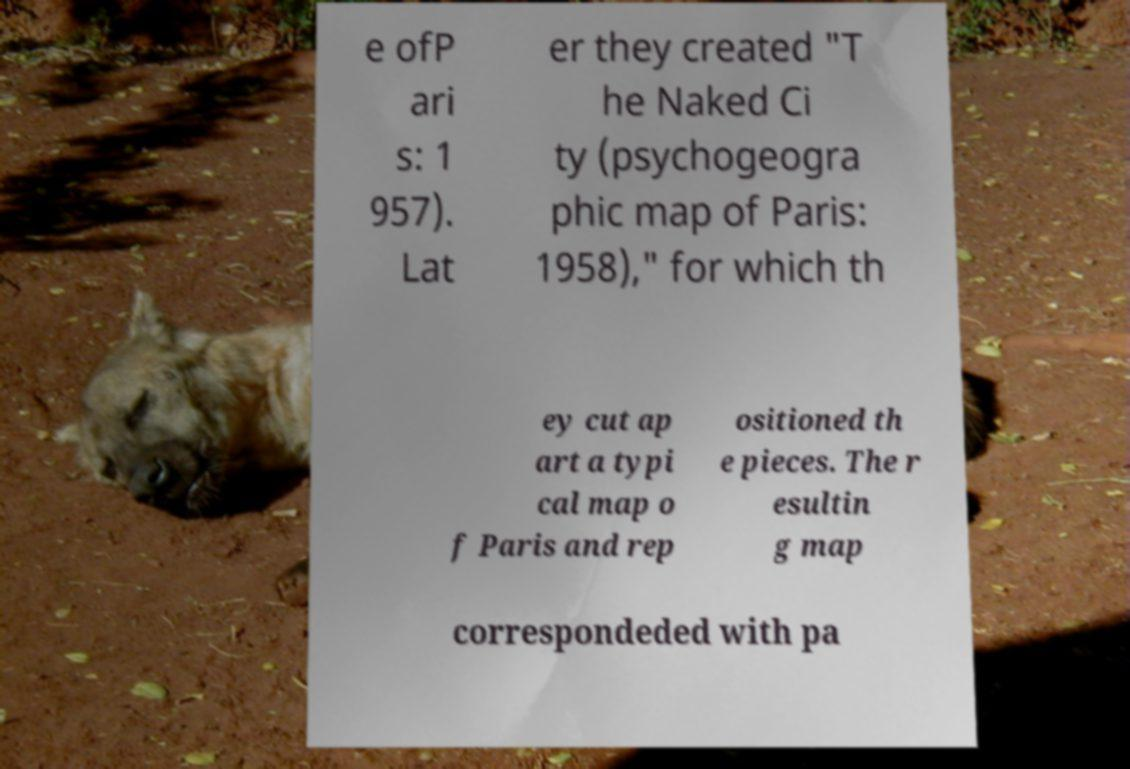Can you read and provide the text displayed in the image?This photo seems to have some interesting text. Can you extract and type it out for me? e ofP ari s: 1 957). Lat er they created "T he Naked Ci ty (psychogeogra phic map of Paris: 1958)," for which th ey cut ap art a typi cal map o f Paris and rep ositioned th e pieces. The r esultin g map correspondeded with pa 